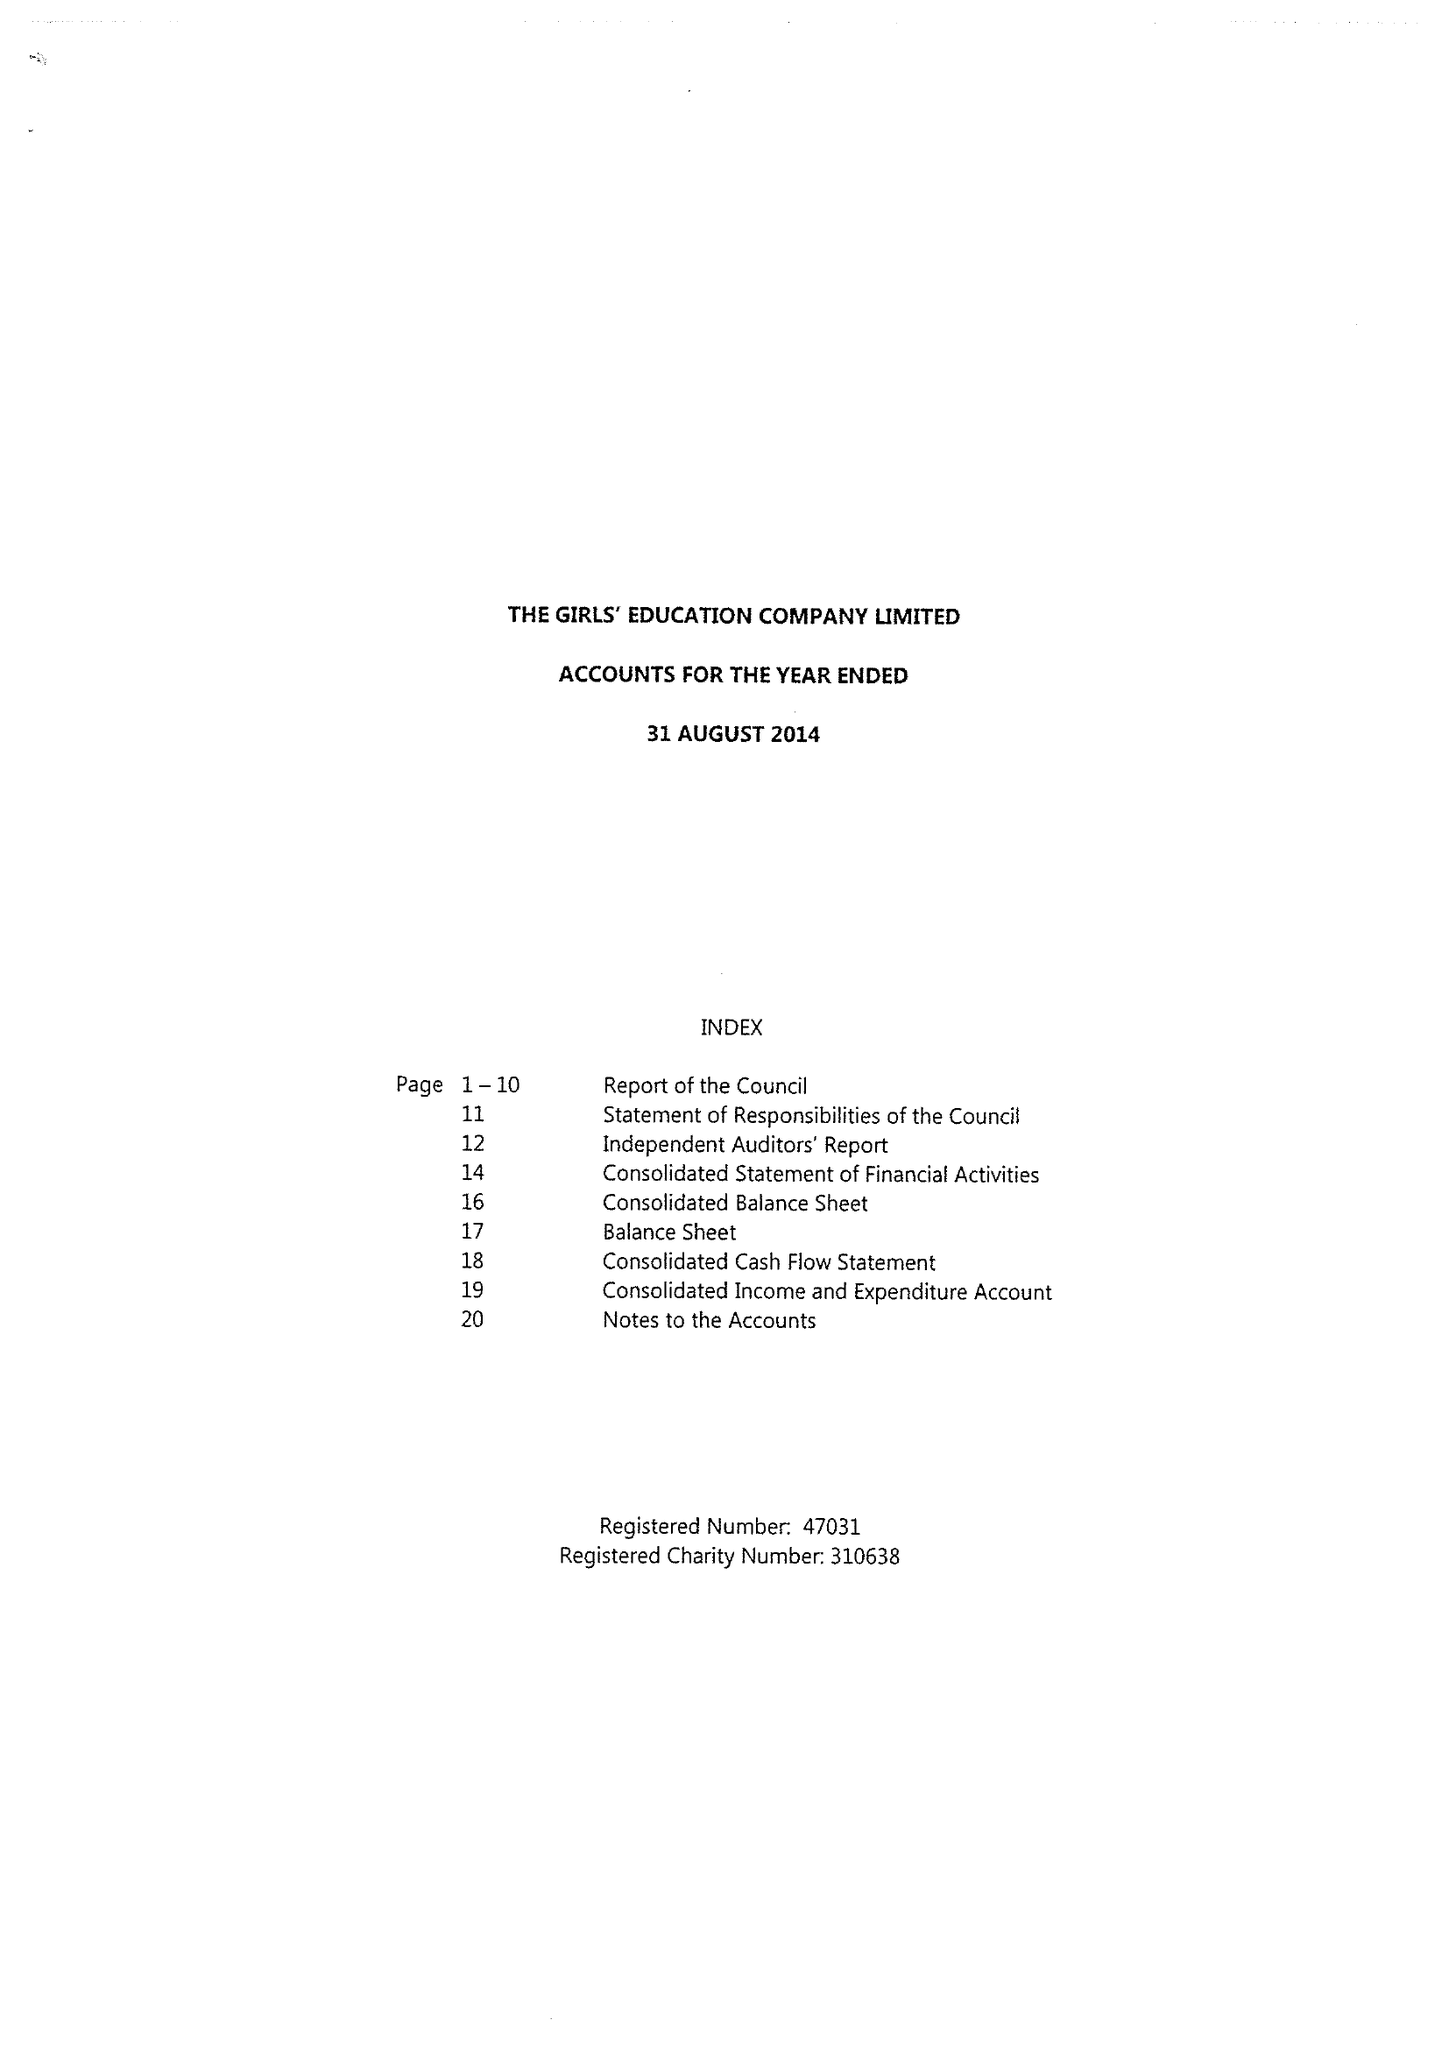What is the value for the address__street_line?
Answer the question using a single word or phrase. ABBEY WAY 